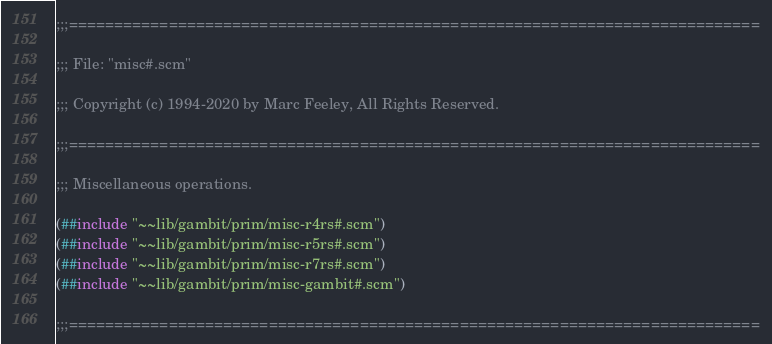<code> <loc_0><loc_0><loc_500><loc_500><_Scheme_>;;;============================================================================

;;; File: "misc#.scm"

;;; Copyright (c) 1994-2020 by Marc Feeley, All Rights Reserved.

;;;============================================================================

;;; Miscellaneous operations.

(##include "~~lib/gambit/prim/misc-r4rs#.scm")
(##include "~~lib/gambit/prim/misc-r5rs#.scm")
(##include "~~lib/gambit/prim/misc-r7rs#.scm")
(##include "~~lib/gambit/prim/misc-gambit#.scm")

;;;============================================================================
</code> 